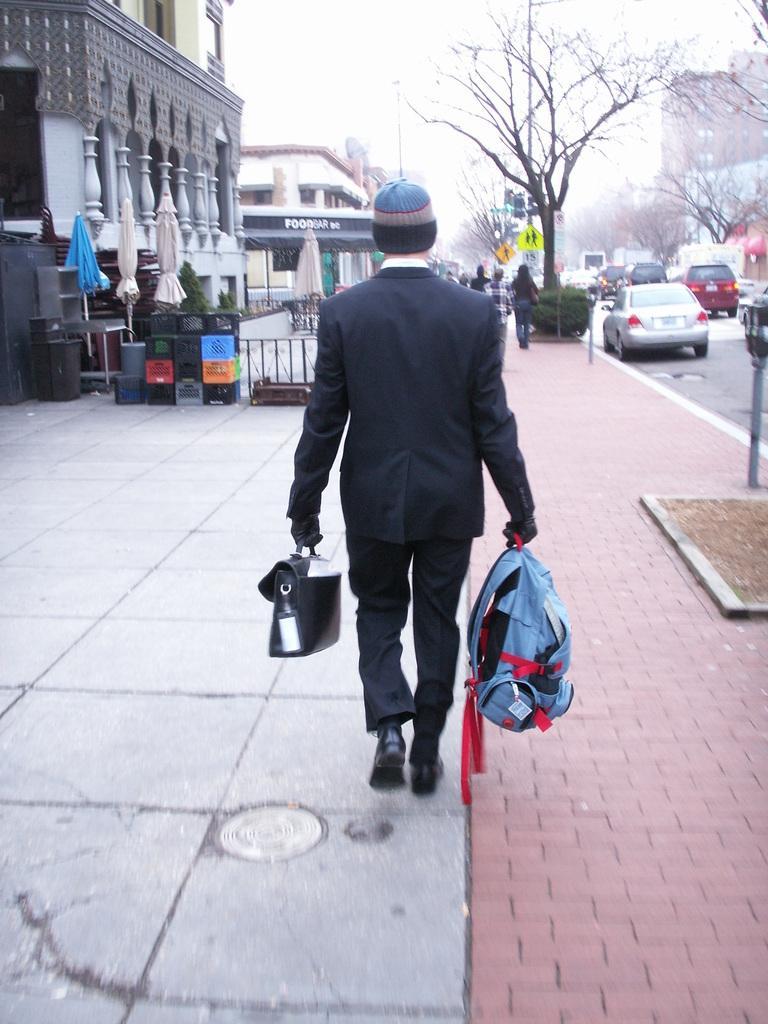Can you describe this image briefly? Here we can see a man walking on the road with bags in his hands and in front of him we can see cars, buildings and trees 